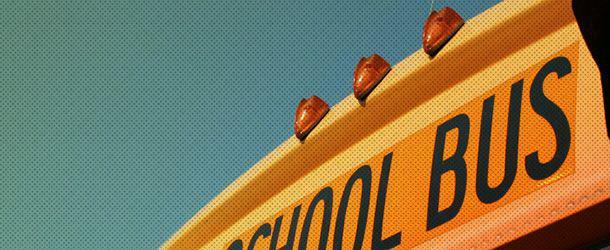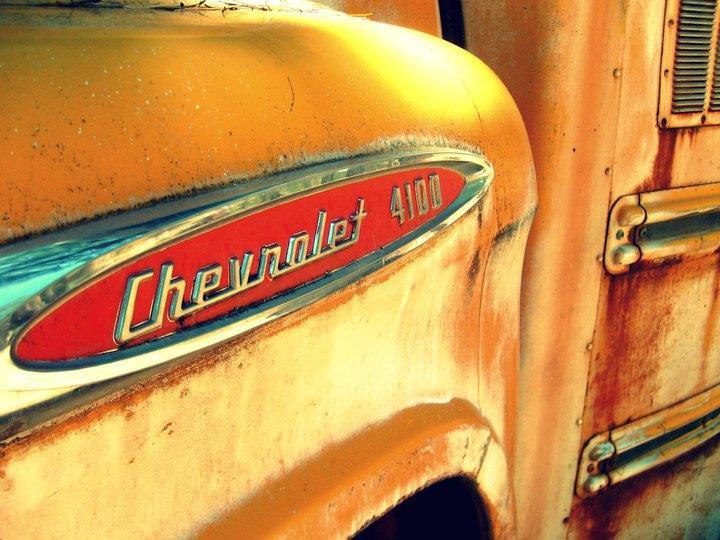The first image is the image on the left, the second image is the image on the right. Given the left and right images, does the statement "The buses on the right are parked in two columns that are close together." hold true? Answer yes or no. No. The first image is the image on the left, the second image is the image on the right. Analyze the images presented: Is the assertion "One image shows parked yellow school buses viewed through chain link fence, and the other image shows a 'diminishing perspective' view of the length of at least one bus." valid? Answer yes or no. No. 